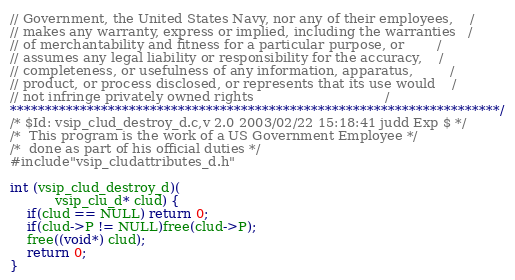Convert code to text. <code><loc_0><loc_0><loc_500><loc_500><_C_>// Government, the United States Navy, nor any of their employees,    /
// makes any warranty, express or implied, including the warranties   /
// of merchantability and fitness for a particular purpose, or        /
// assumes any legal liability or responsibility for the accuracy,    /
// completeness, or usefulness of any information, apparatus,         /
// product, or process disclosed, or represents that its use would    /
// not infringe privately owned rights                                /
**********************************************************************/
/* $Id: vsip_clud_destroy_d.c,v 2.0 2003/02/22 15:18:41 judd Exp $ */
/*  This program is the work of a US Government Employee */
/*  done as part of his official duties */
#include"vsip_cludattributes_d.h"

int (vsip_clud_destroy_d)( 
           vsip_clu_d* clud) {
    if(clud == NULL) return 0;
    if(clud->P != NULL)free(clud->P);
    free((void*) clud);
    return 0;
}
</code> 